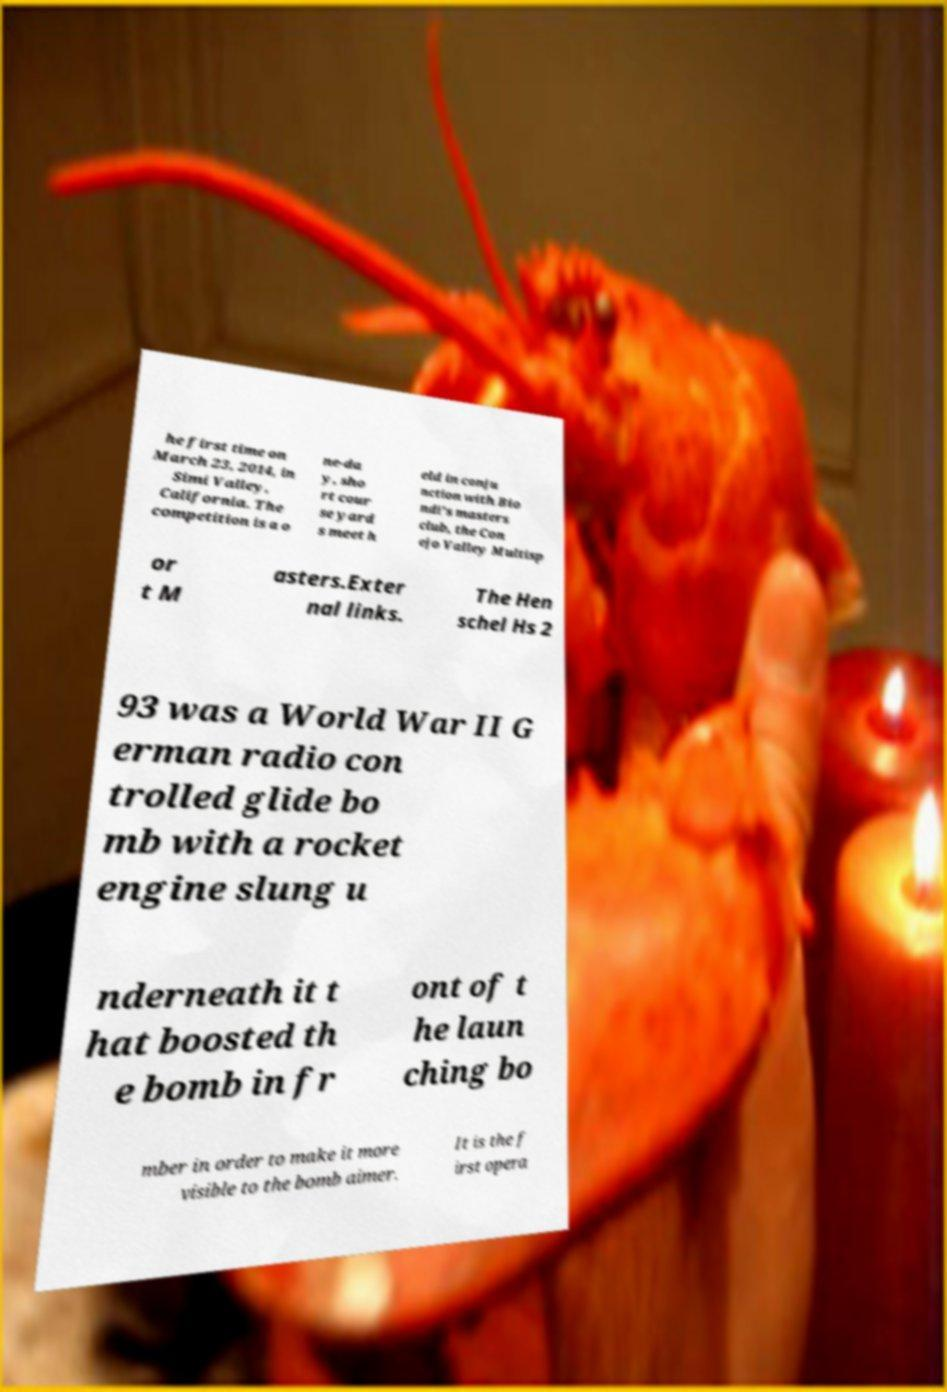What messages or text are displayed in this image? I need them in a readable, typed format. he first time on March 23, 2014, in Simi Valley, California. The competition is a o ne-da y, sho rt cour se yard s meet h eld in conju nction with Bio ndi's masters club, the Con ejo Valley Multisp or t M asters.Exter nal links. The Hen schel Hs 2 93 was a World War II G erman radio con trolled glide bo mb with a rocket engine slung u nderneath it t hat boosted th e bomb in fr ont of t he laun ching bo mber in order to make it more visible to the bomb aimer. It is the f irst opera 